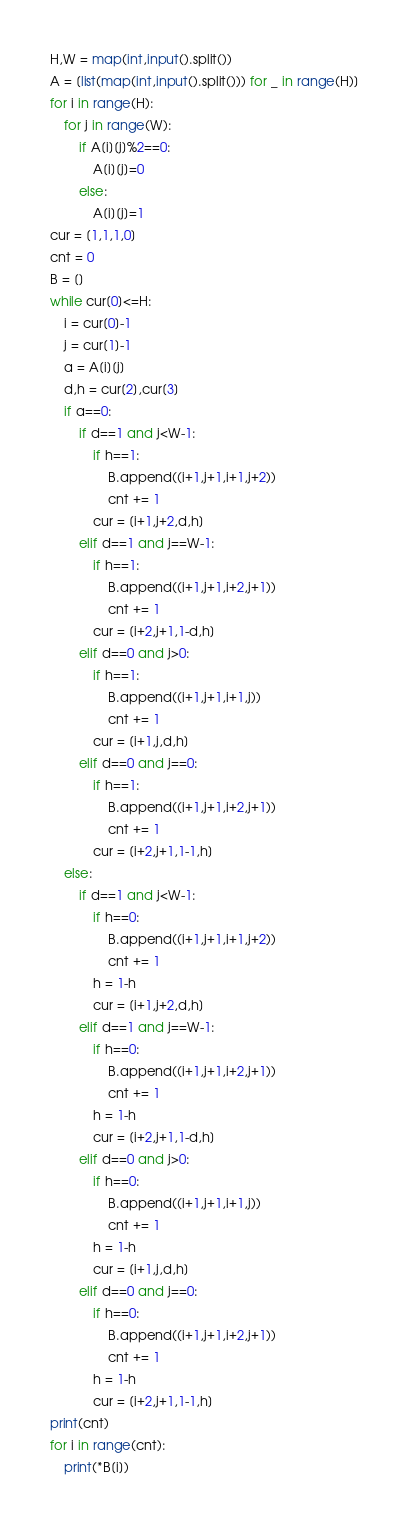<code> <loc_0><loc_0><loc_500><loc_500><_Python_>H,W = map(int,input().split())
A = [list(map(int,input().split())) for _ in range(H)]
for i in range(H):
    for j in range(W):
        if A[i][j]%2==0:
            A[i][j]=0
        else:
            A[i][j]=1
cur = [1,1,1,0]
cnt = 0
B = []
while cur[0]<=H:
    i = cur[0]-1
    j = cur[1]-1
    a = A[i][j]
    d,h = cur[2],cur[3]
    if a==0:
        if d==1 and j<W-1:
            if h==1:
                B.append((i+1,j+1,i+1,j+2))
                cnt += 1
            cur = [i+1,j+2,d,h]
        elif d==1 and j==W-1:
            if h==1:
                B.append((i+1,j+1,i+2,j+1))
                cnt += 1
            cur = [i+2,j+1,1-d,h]
        elif d==0 and j>0:
            if h==1:
                B.append((i+1,j+1,i+1,j))
                cnt += 1
            cur = [i+1,j,d,h]
        elif d==0 and j==0:
            if h==1:
                B.append((i+1,j+1,i+2,j+1))
                cnt += 1
            cur = [i+2,j+1,1-1,h]
    else:
        if d==1 and j<W-1:
            if h==0:
                B.append((i+1,j+1,i+1,j+2))
                cnt += 1
            h = 1-h
            cur = [i+1,j+2,d,h]
        elif d==1 and j==W-1:
            if h==0:
                B.append((i+1,j+1,i+2,j+1))
                cnt += 1
            h = 1-h
            cur = [i+2,j+1,1-d,h]
        elif d==0 and j>0:
            if h==0:
                B.append((i+1,j+1,i+1,j))
                cnt += 1
            h = 1-h
            cur = [i+1,j,d,h]
        elif d==0 and j==0:
            if h==0:
                B.append((i+1,j+1,i+2,j+1))
                cnt += 1
            h = 1-h
            cur = [i+2,j+1,1-1,h]
print(cnt)
for i in range(cnt):
    print(*B[i])</code> 